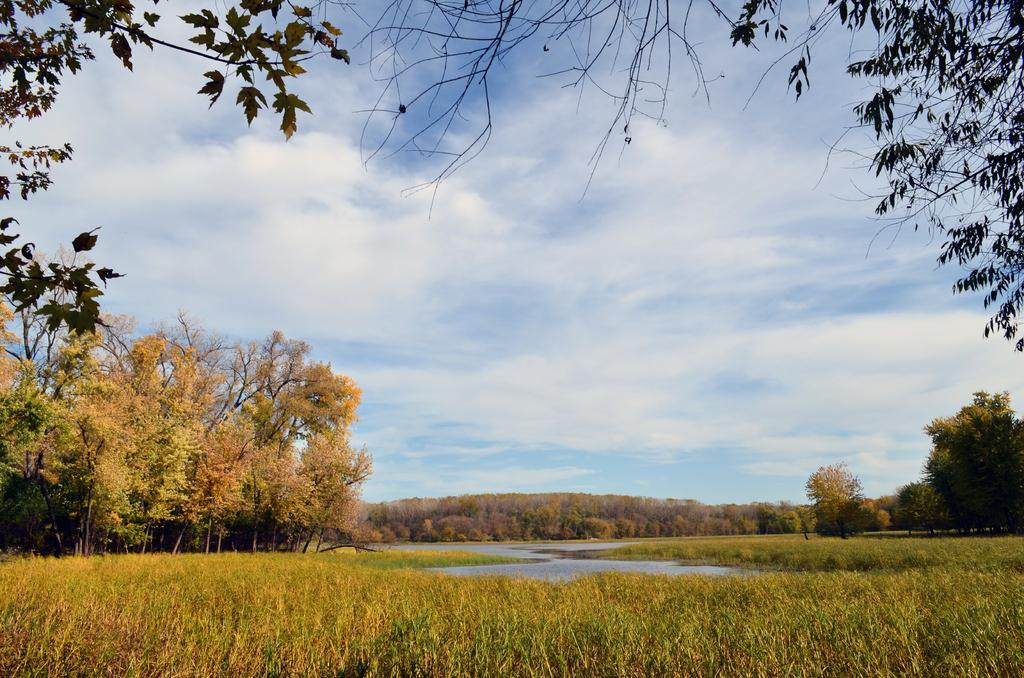What type of vegetation is in the front of the image? There is grass in the front of the image. What can be seen in the background of the image? There are trees in the background of the image. What is the water visible in the image? The water is visible in the image, but its specific location or purpose is not mentioned. What is the condition of the sky in the image? The sky is cloudy in the image. What type of flowers are being used for religious ceremonies in the image? There are no flowers or religious ceremonies depicted in the image. What flavor of cake is being served in the image? There is no cake present in the image. 